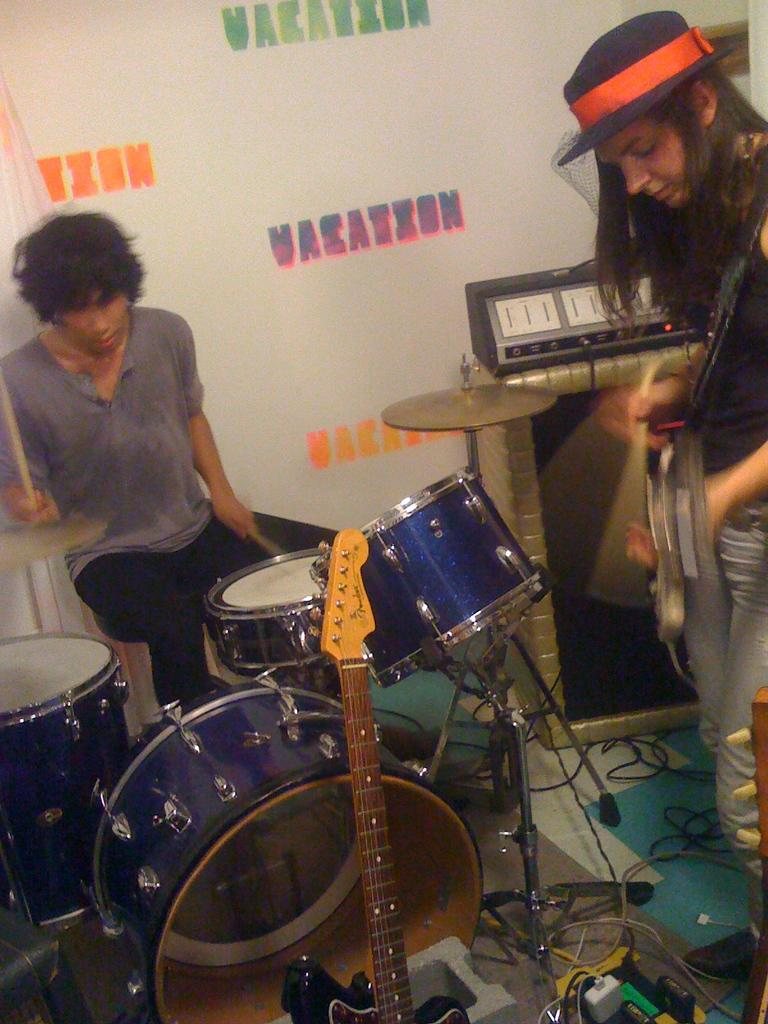How many people are in the image? There are two persons in the image. What is the person on the left doing? The person on the left is playing musical instruments. What color is the background of the image? The background of the image is white. Is there any text or writing visible in the image? Yes, there is writing on the background. What type of shirt is the person on the right wearing in the image? There is no person on the right in the image; there are only two persons, and both are on the left side. Can you describe the patches on the plants in the image? There are no plants present in the image, so there are no patches to describe. 